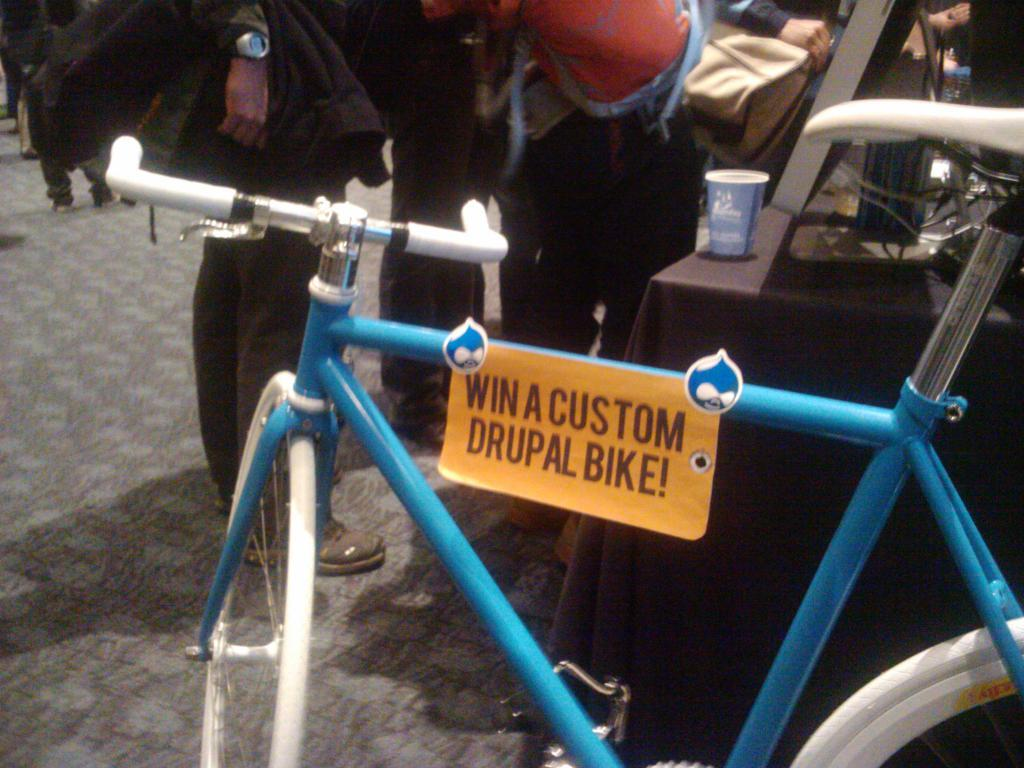What is the main object in the image? There is a bicycle in the image. Are there any distinguishing features on the bicycle? Yes, the bicycle has a sticker on it. What other objects can be seen in the image? There is a table, a monitor, and a glass on the table. Are there any people in the image? Yes, there are people standing on the ground in the image. What type of book is on the chair in the image? There is no chair or book present in the image. What kind of church can be seen in the background of the image? There is no church visible in the image. 